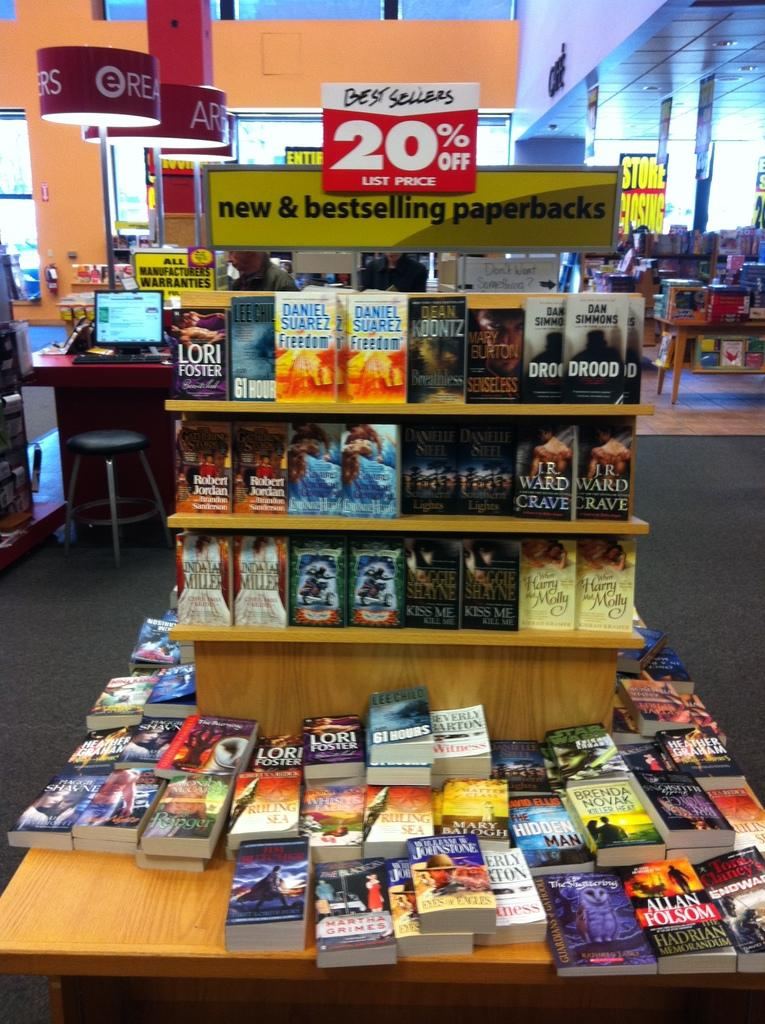<image>
Create a compact narrative representing the image presented. The red sale sign has the sale price of 20% on it 